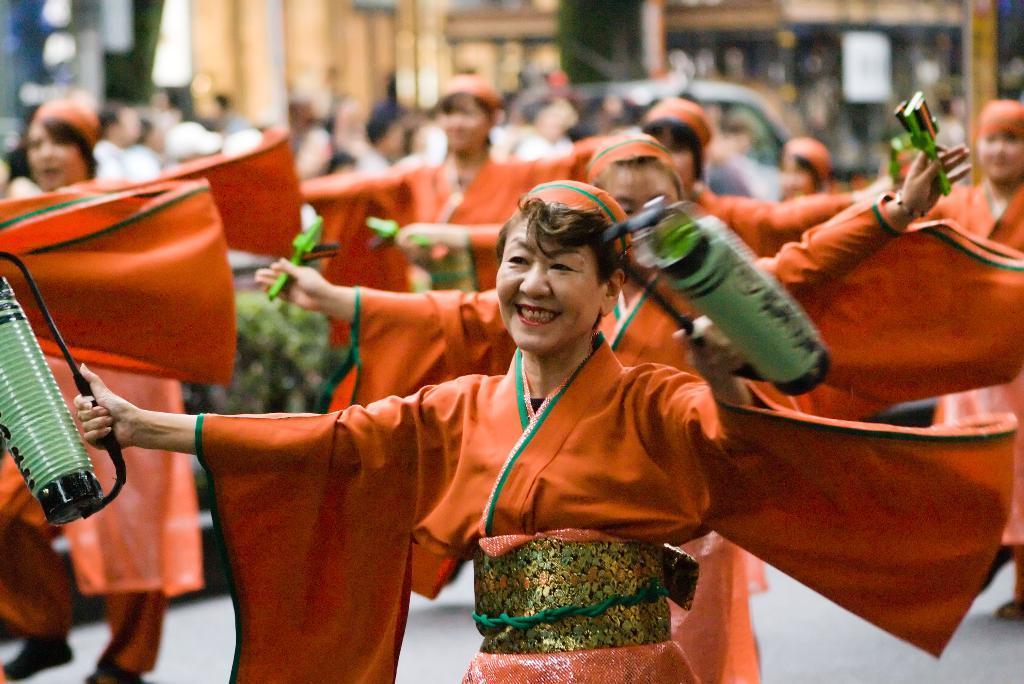Describe this image in one or two sentences. In this image in the middle, there is a woman, she is dancing, behind her there are women, they are dancing, they are holding some items. In the background there are many people, car, buildings. At the bottom there is road. 